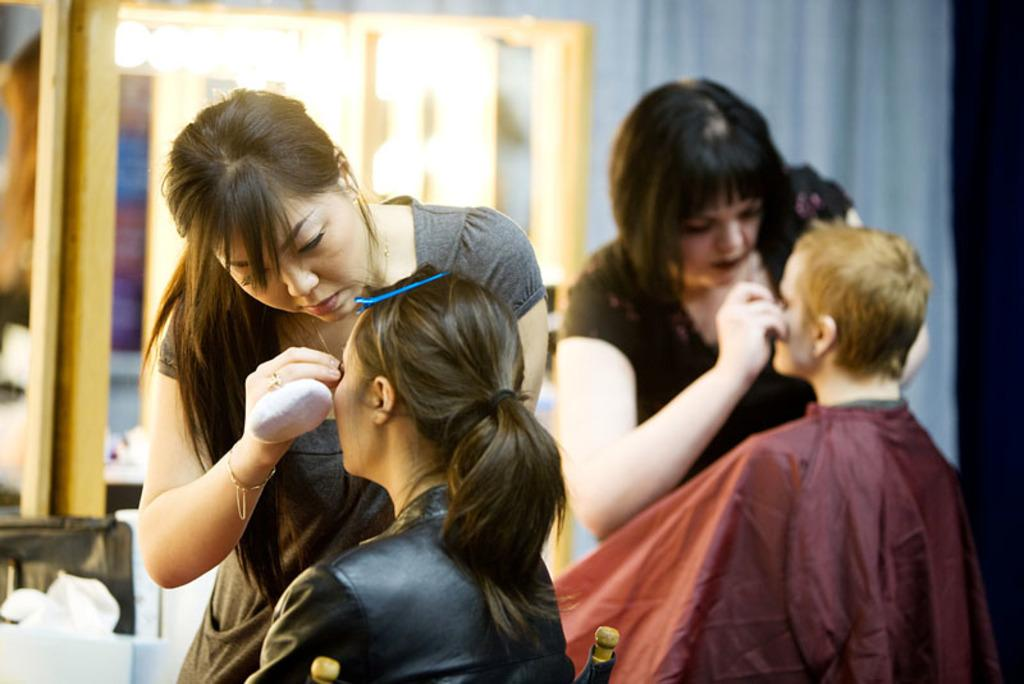What type of room is depicted in the image? The image depicts a room that resembles a saloon. Are there any people in the room? Yes, there are people in the room. How many people are sitting in the room? Two people are sitting in the room. How many people are standing in the room? Two people are standing in the room. What are the standing individuals doing to the sitting persons? The standing individuals are performing makeovers on the sitting persons. Are there any rings visible in the image? A: There are no rings visible in the image. 